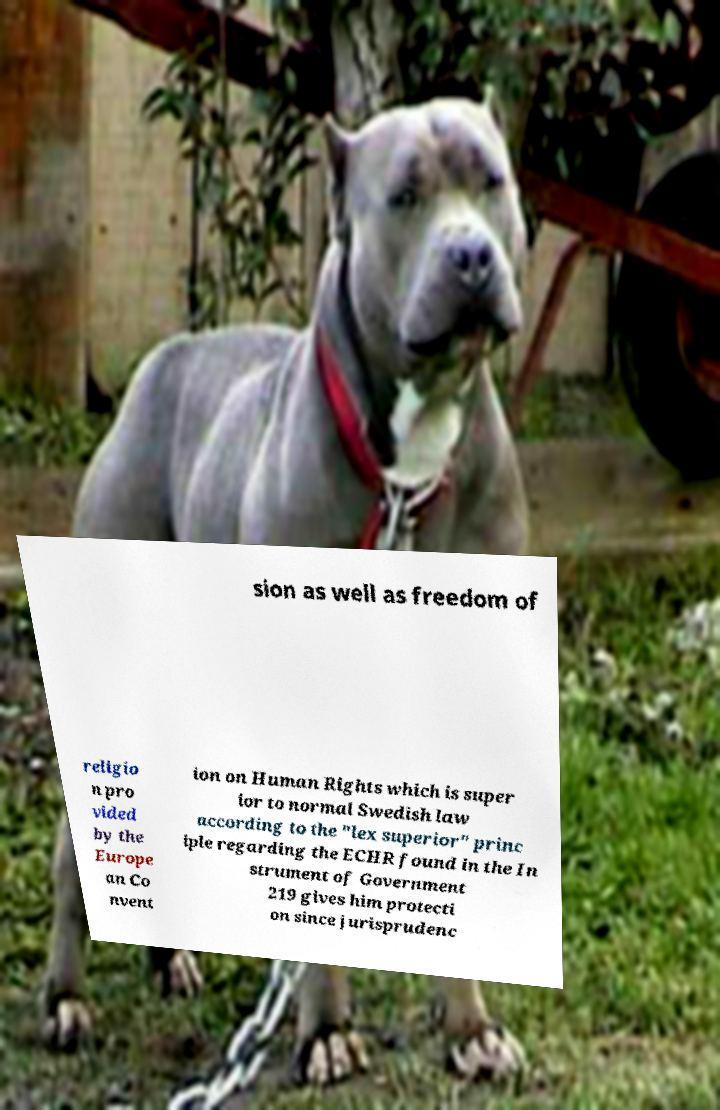Can you accurately transcribe the text from the provided image for me? sion as well as freedom of religio n pro vided by the Europe an Co nvent ion on Human Rights which is super ior to normal Swedish law according to the "lex superior" princ iple regarding the ECHR found in the In strument of Government 219 gives him protecti on since jurisprudenc 